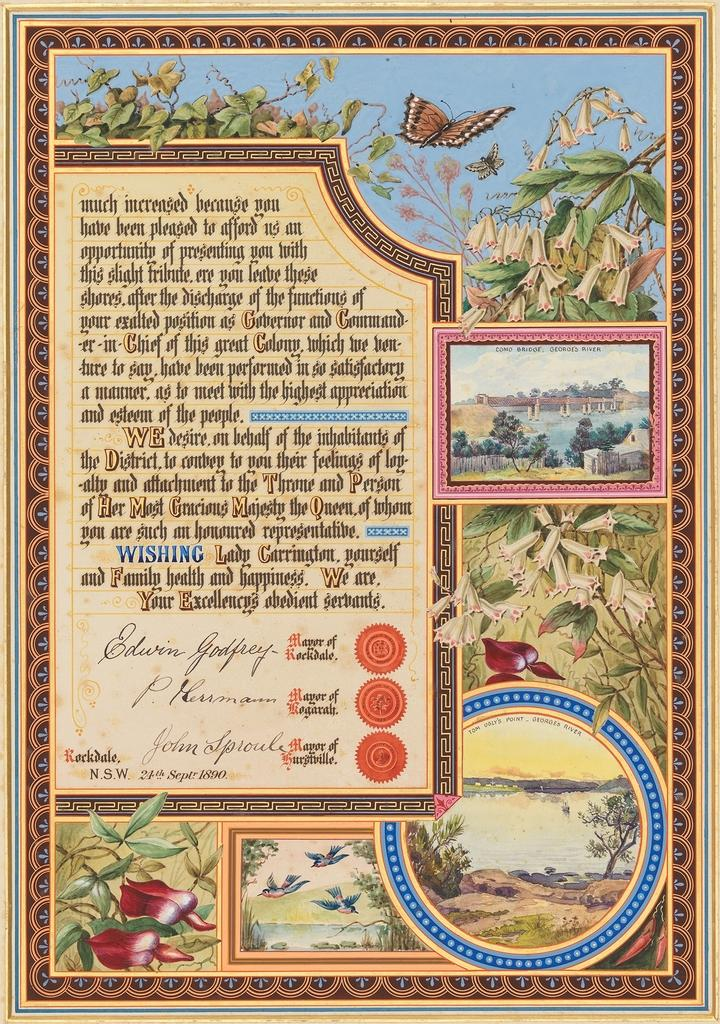<image>
Present a compact description of the photo's key features. Edwin Godfrey is the signature shown on the bottom of this poster. 